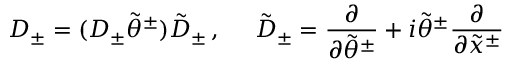<formula> <loc_0><loc_0><loc_500><loc_500>D _ { \pm } = ( D _ { \pm } \tilde { \theta } ^ { \pm } ) \tilde { D } _ { \pm } \, , \tilde { D } _ { \pm } = \frac { \partial } { \partial \tilde { \theta } ^ { \pm } } + i \tilde { \theta } ^ { \pm } \frac { \partial } { \partial \tilde { x } ^ { \pm } }</formula> 